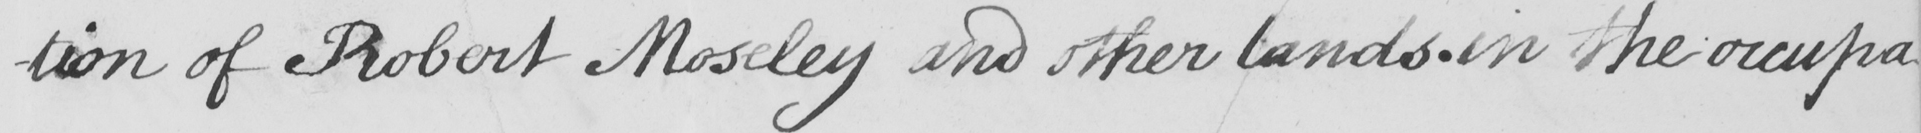Can you tell me what this handwritten text says? -tion of Robert Moseley and other lands in the occupa- 